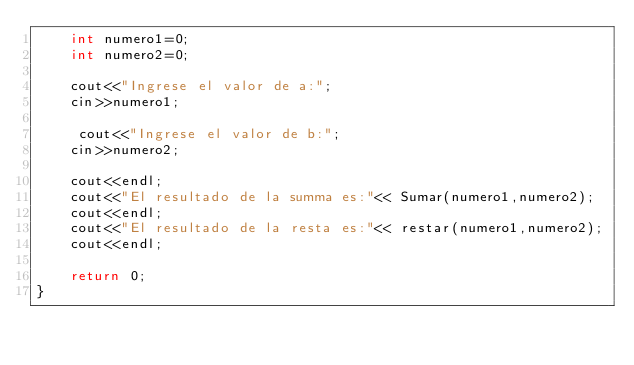<code> <loc_0><loc_0><loc_500><loc_500><_C++_>	int numero1=0;
	int numero2=0;
	
	cout<<"Ingrese el valor de a:";
	cin>>numero1;
	 
	 cout<<"Ingrese el valor de b:";
	cin>>numero2;
	
	cout<<endl;
	cout<<"El resultado de la summa es:"<< Sumar(numero1,numero2);
	cout<<endl;
	cout<<"El resultado de la resta es:"<< restar(numero1,numero2);
	cout<<endl;
	
	return 0;
}
</code> 